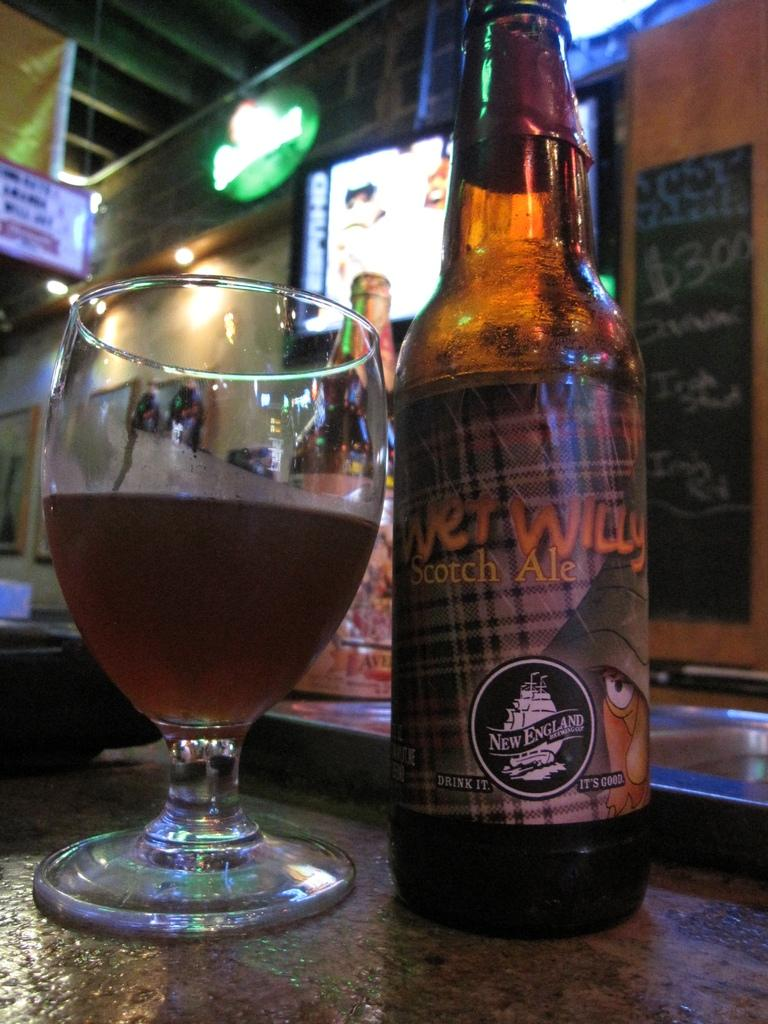<image>
Write a terse but informative summary of the picture. A bottle of Wet Willy Scotch ale is made by the New England Brewing company. 